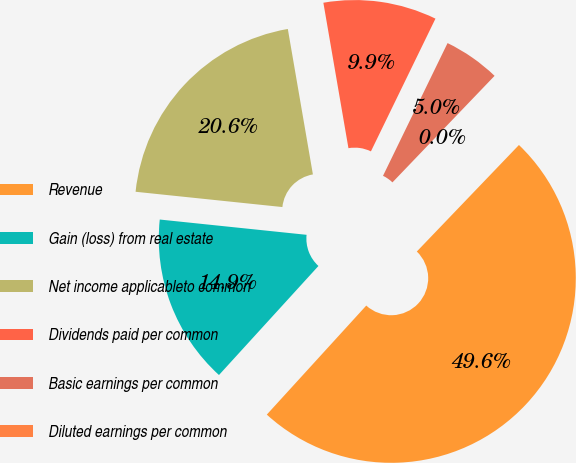Convert chart. <chart><loc_0><loc_0><loc_500><loc_500><pie_chart><fcel>Revenue<fcel>Gain (loss) from real estate<fcel>Net income applicableto common<fcel>Dividends paid per common<fcel>Basic earnings per common<fcel>Diluted earnings per common<nl><fcel>49.6%<fcel>14.88%<fcel>20.63%<fcel>9.92%<fcel>4.96%<fcel>0.0%<nl></chart> 